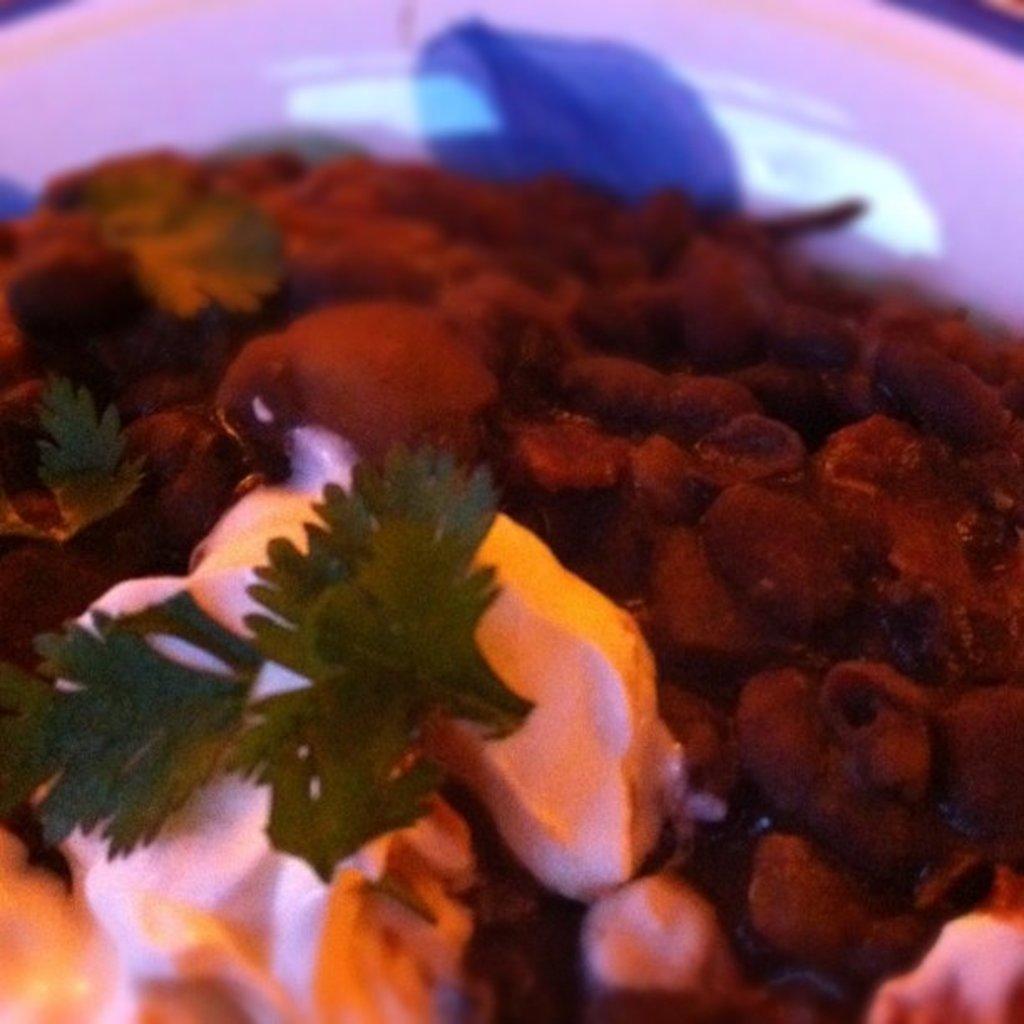Describe this image in one or two sentences. This image consists of food it looks like a meet along with coriander kept on a plate. The plate is in white color. 